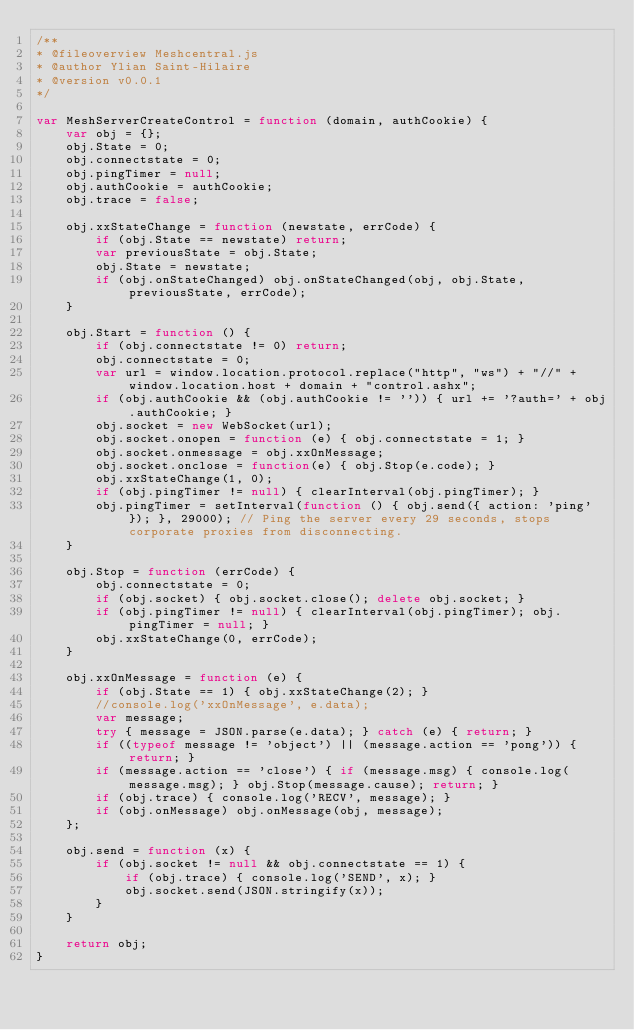<code> <loc_0><loc_0><loc_500><loc_500><_JavaScript_>/** 
* @fileoverview Meshcentral.js
* @author Ylian Saint-Hilaire
* @version v0.0.1
*/

var MeshServerCreateControl = function (domain, authCookie) {
    var obj = {};
    obj.State = 0;
    obj.connectstate = 0;
    obj.pingTimer = null;
    obj.authCookie = authCookie;
    obj.trace = false;
    
    obj.xxStateChange = function (newstate, errCode) {
        if (obj.State == newstate) return;
        var previousState = obj.State;
        obj.State = newstate;
        if (obj.onStateChanged) obj.onStateChanged(obj, obj.State, previousState, errCode);
    }

    obj.Start = function () {
        if (obj.connectstate != 0) return;
        obj.connectstate = 0;
        var url = window.location.protocol.replace("http", "ws") + "//" + window.location.host + domain + "control.ashx";
        if (obj.authCookie && (obj.authCookie != '')) { url += '?auth=' + obj.authCookie; }
        obj.socket = new WebSocket(url);
        obj.socket.onopen = function (e) { obj.connectstate = 1; }
        obj.socket.onmessage = obj.xxOnMessage;
        obj.socket.onclose = function(e) { obj.Stop(e.code); }
        obj.xxStateChange(1, 0);
        if (obj.pingTimer != null) { clearInterval(obj.pingTimer); }
        obj.pingTimer = setInterval(function () { obj.send({ action: 'ping' }); }, 29000); // Ping the server every 29 seconds, stops corporate proxies from disconnecting.
    }
    
    obj.Stop = function (errCode) {
        obj.connectstate = 0;
        if (obj.socket) { obj.socket.close(); delete obj.socket; }
        if (obj.pingTimer != null) { clearInterval(obj.pingTimer); obj.pingTimer = null; }
        obj.xxStateChange(0, errCode);
    }
    
    obj.xxOnMessage = function (e) {
        if (obj.State == 1) { obj.xxStateChange(2); }
        //console.log('xxOnMessage', e.data);
        var message;
        try { message = JSON.parse(e.data); } catch (e) { return; }
        if ((typeof message != 'object') || (message.action == 'pong')) { return; }
        if (message.action == 'close') { if (message.msg) { console.log(message.msg); } obj.Stop(message.cause); return; }
        if (obj.trace) { console.log('RECV', message); }
        if (obj.onMessage) obj.onMessage(obj, message);
    };
    
    obj.send = function (x) {
        if (obj.socket != null && obj.connectstate == 1) {
            if (obj.trace) { console.log('SEND', x); }
            obj.socket.send(JSON.stringify(x));
        }
    }

    return obj;    
}
</code> 